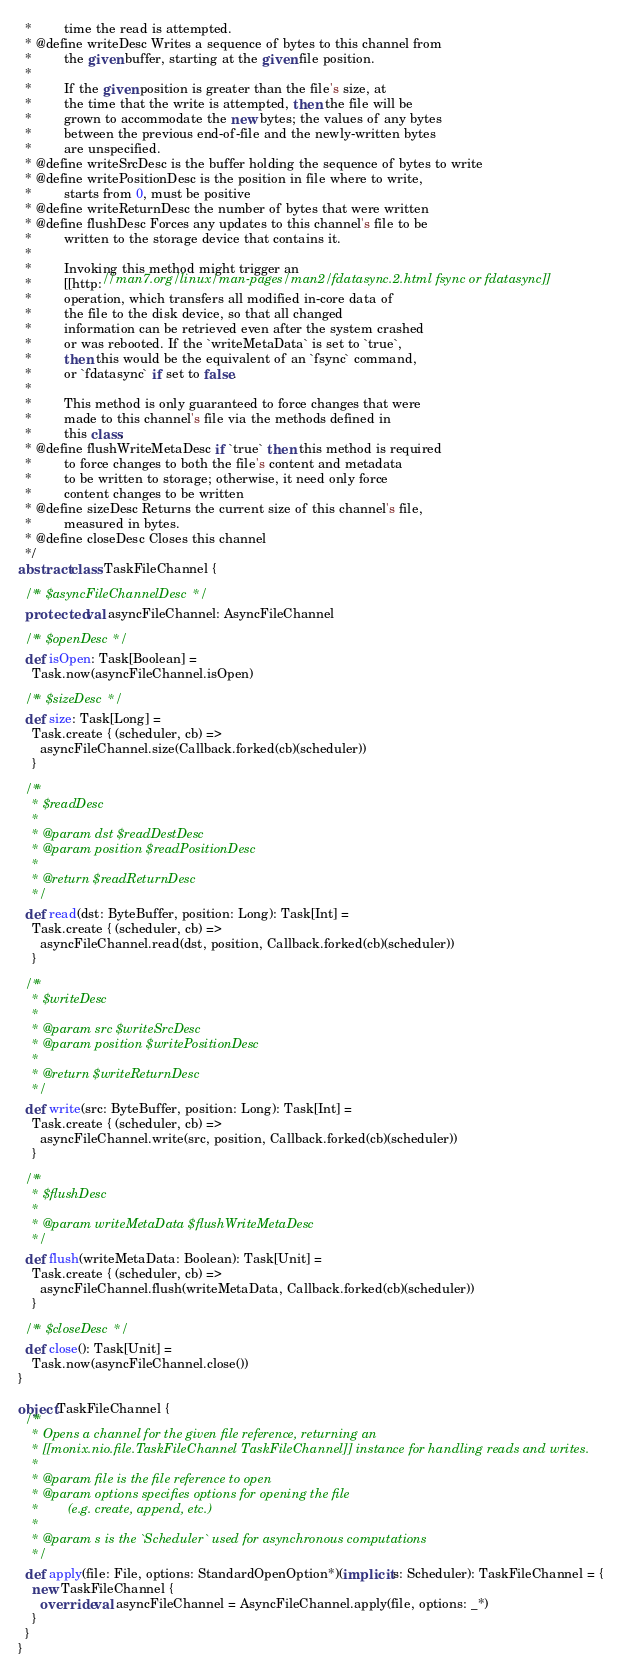<code> <loc_0><loc_0><loc_500><loc_500><_Scala_>  *         time the read is attempted.
  * @define writeDesc Writes a sequence of bytes to this channel from
  *         the given buffer, starting at the given file position.
  *
  *         If the given position is greater than the file's size, at
  *         the time that the write is attempted, then the file will be
  *         grown to accommodate the new bytes; the values of any bytes
  *         between the previous end-of-file and the newly-written bytes
  *         are unspecified.
  * @define writeSrcDesc is the buffer holding the sequence of bytes to write
  * @define writePositionDesc is the position in file where to write,
  *         starts from 0, must be positive
  * @define writeReturnDesc the number of bytes that were written
  * @define flushDesc Forces any updates to this channel's file to be
  *         written to the storage device that contains it.
  *
  *         Invoking this method might trigger an
  *         [[http://man7.org/linux/man-pages/man2/fdatasync.2.html fsync or fdatasync]]
  *         operation, which transfers all modified in-core data of
  *         the file to the disk device, so that all changed
  *         information can be retrieved even after the system crashed
  *         or was rebooted. If the `writeMetaData` is set to `true`,
  *         then this would be the equivalent of an `fsync` command,
  *         or `fdatasync` if set to false.
  *
  *         This method is only guaranteed to force changes that were
  *         made to this channel's file via the methods defined in
  *         this class.
  * @define flushWriteMetaDesc if `true` then this method is required
  *         to force changes to both the file's content and metadata
  *         to be written to storage; otherwise, it need only force
  *         content changes to be written
  * @define sizeDesc Returns the current size of this channel's file,
  *         measured in bytes.
  * @define closeDesc Closes this channel
  */
abstract class TaskFileChannel {

  /** $asyncFileChannelDesc */
  protected val asyncFileChannel: AsyncFileChannel

  /** $openDesc */
  def isOpen: Task[Boolean] =
    Task.now(asyncFileChannel.isOpen)

  /** $sizeDesc */
  def size: Task[Long] =
    Task.create { (scheduler, cb) =>
      asyncFileChannel.size(Callback.forked(cb)(scheduler))
    }

  /**
    * $readDesc
    *
    * @param dst $readDestDesc
    * @param position $readPositionDesc
    *
    * @return $readReturnDesc
    */
  def read(dst: ByteBuffer, position: Long): Task[Int] =
    Task.create { (scheduler, cb) =>
      asyncFileChannel.read(dst, position, Callback.forked(cb)(scheduler))
    }

  /**
    * $writeDesc
    *
    * @param src $writeSrcDesc
    * @param position $writePositionDesc
    *
    * @return $writeReturnDesc
    */
  def write(src: ByteBuffer, position: Long): Task[Int] =
    Task.create { (scheduler, cb) =>
      asyncFileChannel.write(src, position, Callback.forked(cb)(scheduler))
    }

  /**
    * $flushDesc
    *
    * @param writeMetaData $flushWriteMetaDesc
    */
  def flush(writeMetaData: Boolean): Task[Unit] =
    Task.create { (scheduler, cb) =>
      asyncFileChannel.flush(writeMetaData, Callback.forked(cb)(scheduler))
    }

  /** $closeDesc */
  def close(): Task[Unit] =
    Task.now(asyncFileChannel.close())
}

object TaskFileChannel {
  /**
    * Opens a channel for the given file reference, returning an
    * [[monix.nio.file.TaskFileChannel TaskFileChannel]] instance for handling reads and writes.
    *
    * @param file is the file reference to open
    * @param options specifies options for opening the file
    *        (e.g. create, append, etc.)
    *
    * @param s is the `Scheduler` used for asynchronous computations
    */
  def apply(file: File, options: StandardOpenOption*)(implicit s: Scheduler): TaskFileChannel = {
    new TaskFileChannel {
      override val asyncFileChannel = AsyncFileChannel.apply(file, options: _*)
    }
  }
}
</code> 